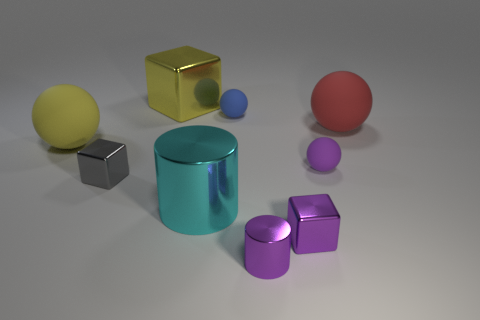What shape is the large red object closest to the foreground? The large red object closest to the foreground is a sphere. Its perfectly round shape is discernable even though it's partially obscured, indicated by its smooth curved surface and circular outline. Do any other objects share the same shape? Yes, there are smaller spheres in the image. There’s a small blue sphere in the center of the arrangement and a tiny purple one to the left of the large red sphere. Each of these spheres shares the characteristic round and symmetrical shape. 